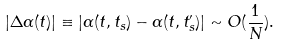<formula> <loc_0><loc_0><loc_500><loc_500>\left | \Delta \alpha ( t ) \right | \equiv \left | \alpha ( t , t _ { s } ) - \alpha ( t , t _ { s } ^ { \prime } ) \right | \sim O ( \frac { 1 } { N } ) .</formula> 